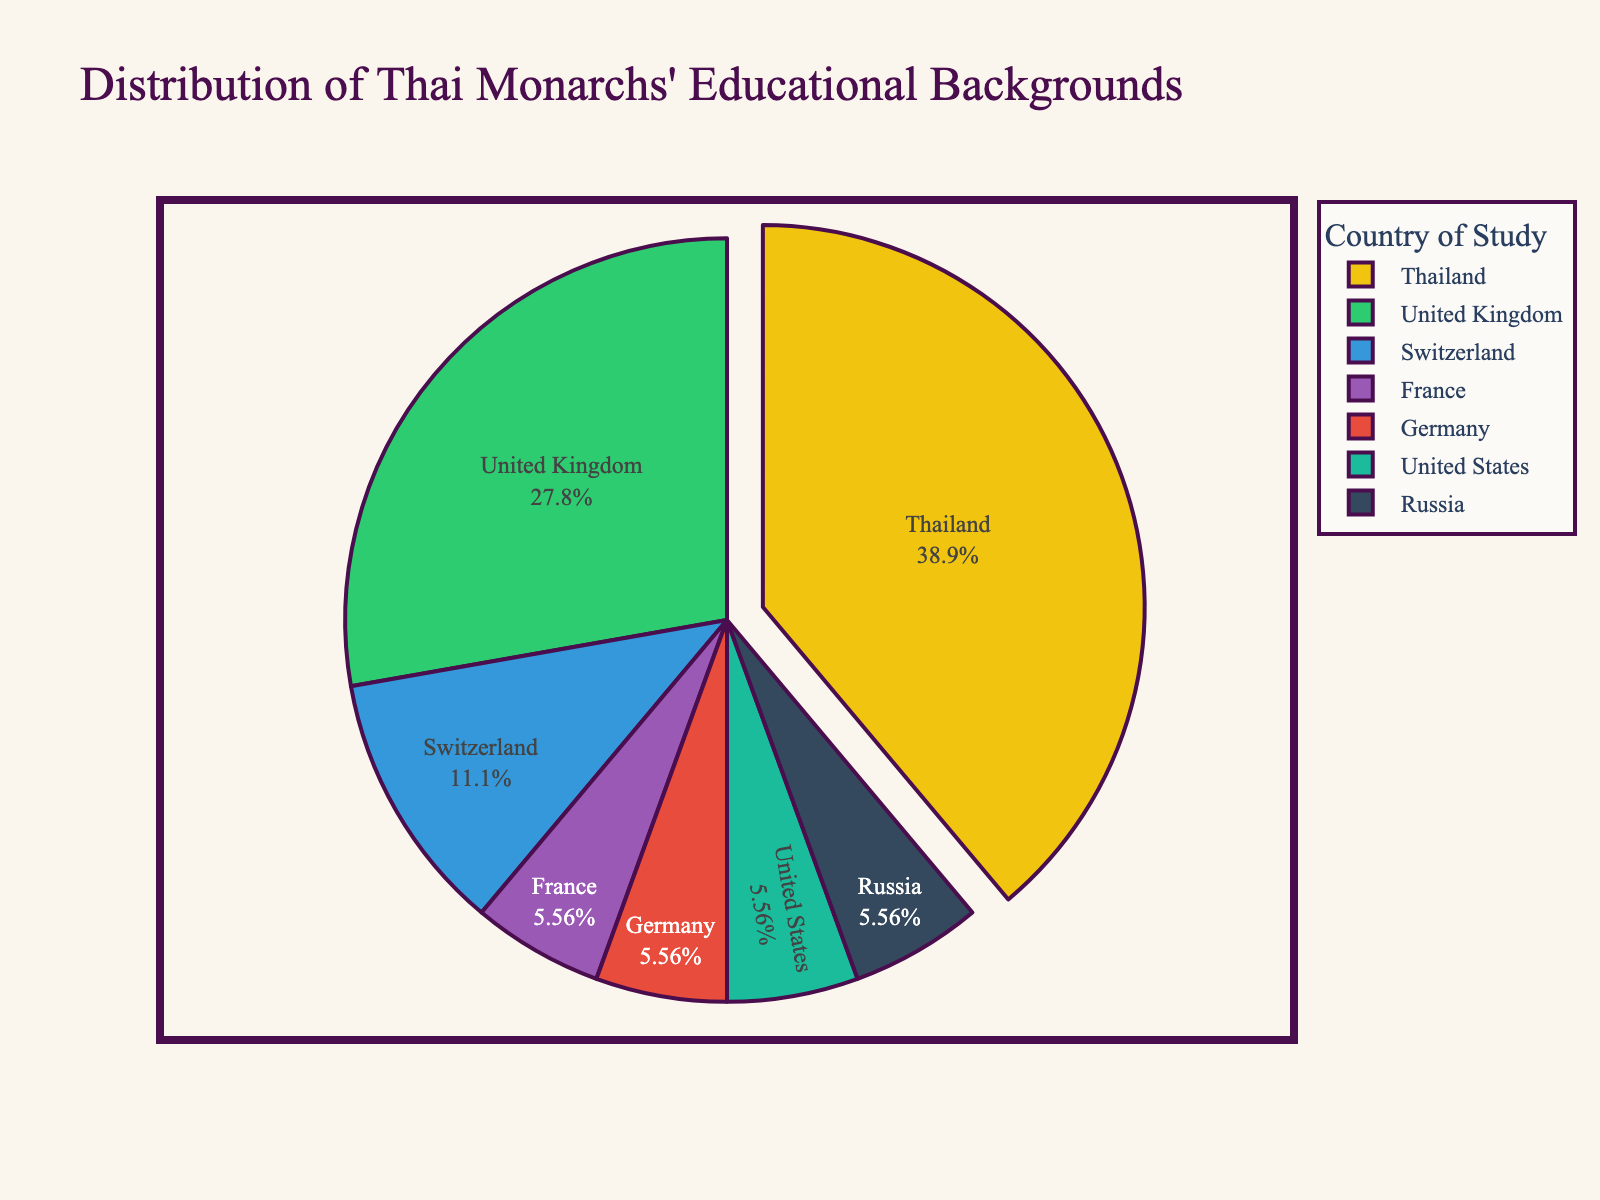What percentage of Thai monarchs studied in Thailand? The chart shows the distribution of Thai monarchs' educational backgrounds. From the pie chart, we see that 7 monarchs studied in Thailand. To find the percentage, we use the formula (7 / total number of monarchs) * 100. The total number of monarchs is 7 (Thailand) + 5 (UK) + 2 (Switzerland) + 1 (France) + 1 (Germany) + 1 (US) + 1 (Russia) = 18. So, (7 / 18) * 100 ≈ 38.89%.
Answer: 38.89% Which country has the second-highest number of Thai monarchs studying there? According to the pie chart, the country with the highest number of Thai monarchs is Thailand with 7 monarchs. The country with the second-highest number is the United Kingdom, with 5 monarchs.
Answer: United Kingdom Is the number of monarchs who studied in both Switzerland and France greater than the number of monarchs who studied in the United Kingdom? The pie chart shows that 2 monarchs studied in Switzerland and 1 monarch studied in France. Together, 2 + 1 = 3 monarchs studied in these two countries. The number of monarchs who studied in the United Kingdom is 5. Since 3 is less than 5, the number of monarchs who studied in Switzerland and France is not greater than those who studied in the UK.
Answer: No How many more monarchs studied in Thailand compared to Germany? The chart indicates that 7 monarchs studied in Thailand and 1 monarch studied in Germany. To find how many more studied in Thailand, we subtract the number of monarchs who studied in Germany from the number in Thailand: 7 - 1 = 6 more monarchs.
Answer: 6 more What is the combined percentage of monarchs who studied in the United States and Russia? The pie chart shows 1 monarch each studied in the United States and Russia. So combined, they account for 1 + 1 = 2 monarchs. The total number of monarchs is 18. To find the percentage: (2 / 18) * 100 ≈ 11.11%.
Answer: 11.11% Are there at least two countries where the same number of Thai monarchs studied? Yes, according to the pie chart, three countries have the same number of monarchs who studied there: France, Germany, and the United States each have 1 monarch.
Answer: Yes What is the difference in the number of monarchs between the country with the most monarchs and the country with the least monarchs? The pie chart indicates Thailand has the most monarchs (7), while multiple countries tie for the least monarchs (France, Germany, United States, Russia each with 1 monarch). The difference between the highest and lowest is 7 - 1 = 6 monarchs.
Answer: 6 monarchs Does any country have exactly half the number of monarchs as Thailand? Thailand has 7 monarchs. Half of 7 is 3.5, which means no country can have exactly half the number of monarchs as Thailand since the number must be an integer. None of the countries listed have 3.5 monarchs.
Answer: No Which countries have monarchs accounting for one-sixth of the total? The total number of monarchs is 18. One-sixth of this total is 18 / 6 = 3. The chart shows that no single country has 3 monarchs. Therefore, no country has monarchs accounting for exactly one-sixth of the total.
Answer: None 